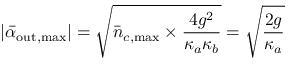Convert formula to latex. <formula><loc_0><loc_0><loc_500><loc_500>| \bar { \alpha } _ { o u t , \max } | = \sqrt { \bar { n } _ { c , \max } \times \frac { 4 g ^ { 2 } } { \kappa _ { a } \kappa _ { b } } } = \sqrt { \frac { 2 g } { \kappa _ { a } } }</formula> 